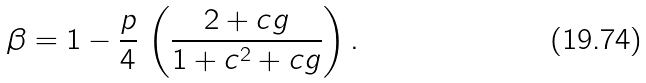Convert formula to latex. <formula><loc_0><loc_0><loc_500><loc_500>\beta = 1 - \frac { p } { 4 } \, \left ( \frac { 2 + c g } { 1 + c ^ { 2 } + c g } \right ) .</formula> 